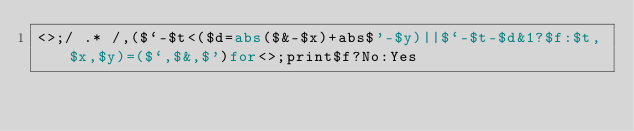Convert code to text. <code><loc_0><loc_0><loc_500><loc_500><_Perl_><>;/ .* /,($`-$t<($d=abs($&-$x)+abs$'-$y)||$`-$t-$d&1?$f:$t,$x,$y)=($`,$&,$')for<>;print$f?No:Yes</code> 